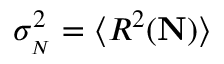<formula> <loc_0><loc_0><loc_500><loc_500>\sigma _ { N } } ^ { 2 } = \langle R ^ { 2 } ( { N } ) \rangle</formula> 